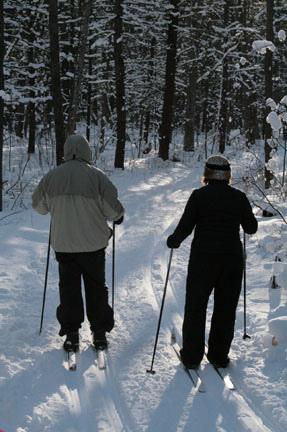What are these two people wearing on their feet?
Quick response, please. Skis. Are the two skiers traveling in the same direction?
Concise answer only. Yes. Is there a trail?
Give a very brief answer. Yes. 